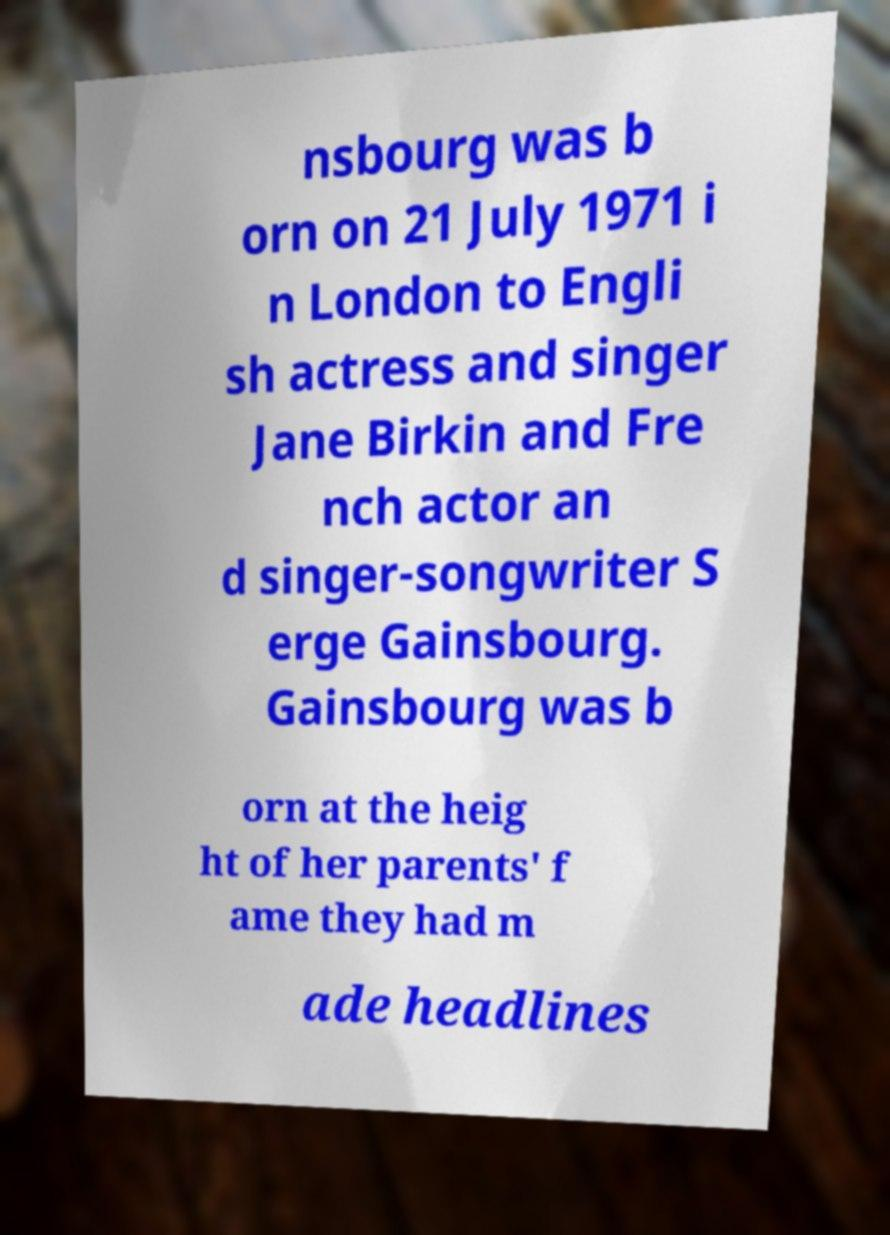For documentation purposes, I need the text within this image transcribed. Could you provide that? nsbourg was b orn on 21 July 1971 i n London to Engli sh actress and singer Jane Birkin and Fre nch actor an d singer-songwriter S erge Gainsbourg. Gainsbourg was b orn at the heig ht of her parents' f ame they had m ade headlines 